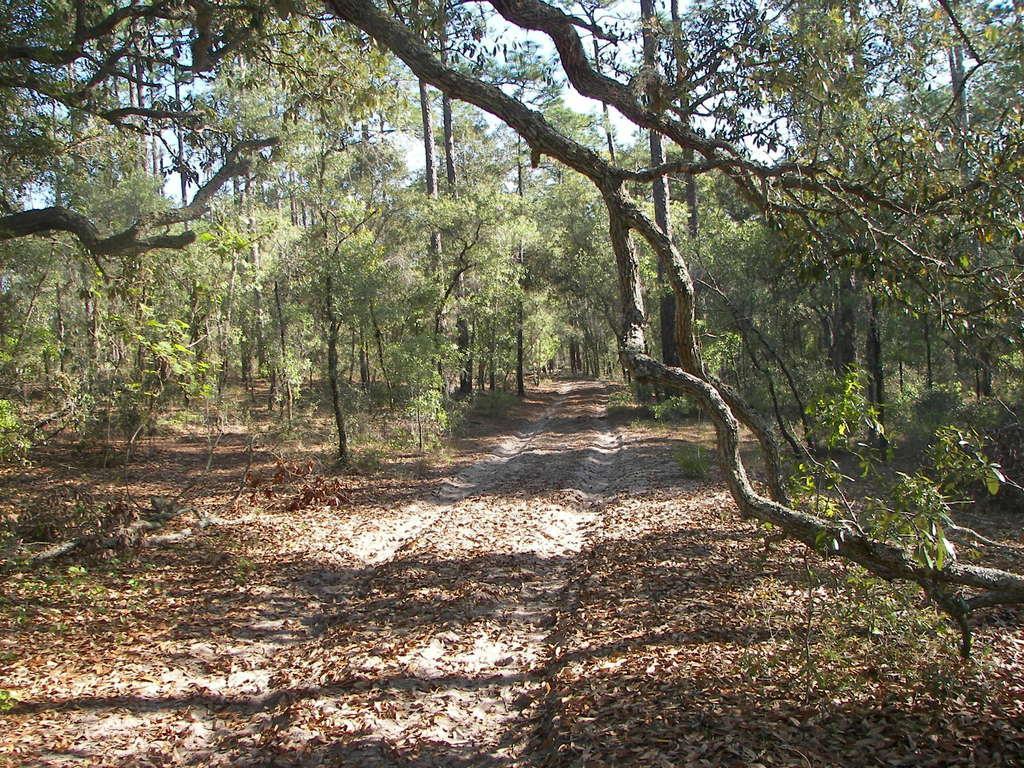In one or two sentences, can you explain what this image depicts? In this picture I can see a path, in between the trees and also we can see some dry leaves on the ground. 